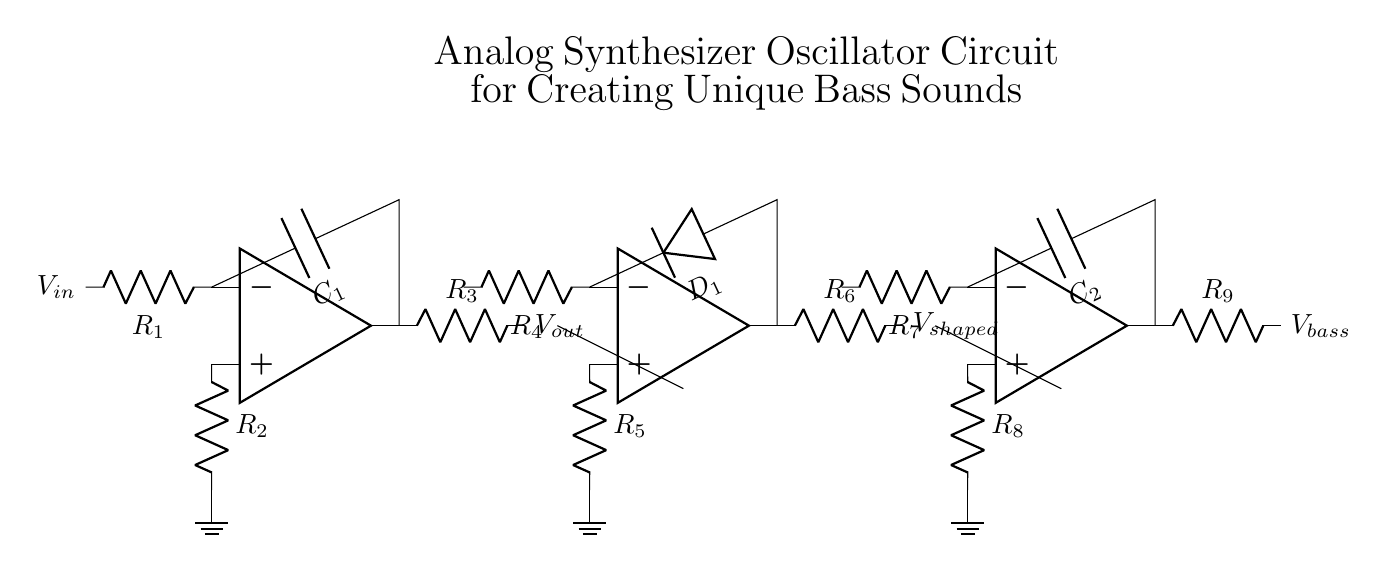what is the type of capacitor used in this circuit? The circuit uses two capacitors labeled as C1 and C2. The type is typically an electrolytic or ceramic capacitor in oscillator circuits, but the specific type isn't clear just from the diagram.
Answer: C1 and C2 what is the resistance value of R1? The circuit diagram does not provide specific resistance values, as they are represented as R1, R2, etc. Thus, their values must be determined from context or specifications of the circuit.
Answer: Not specified how many operational amplifiers are present in the circuit? The diagram displays three operational amplifiers, indicated as nodes that resemble operational amplifier symbols. Each op-amp serves different stages of the circuit.
Answer: Three which component shapes the waveform in the circuit? The waveform shaping is primarily accomplished by the second operational amplifier (designated opamp2) along with resistor R6. The diode D1 also plays a role in this process.
Answer: Opamp2 what type of circuit is represented by this diagram? This diagram represents an analog synthesizer oscillator circuit specifically designed for generating bass sounds. It features multiple stages that include oscillation, waveform shaping, and filtering.
Answer: Analog synthesizer oscillator what is the function of the low-pass filter in this circuit? The low-pass filter, represented by the third operational amplifier (opamp3), smooths out high-frequency signals, allowing only lower frequencies (bass sounds in this context) to pass through. This is essential for generating a clean bass output.
Answer: To filter high frequencies what is the expected output voltage represented as Vout? The output voltage Vout is presented at the output of the first amplifier (opamp) and varies depending on the input signal and configuration of the resistors. Since no specific values are given, the exact voltage isn't determined from the diagram.
Answer: Not specified 